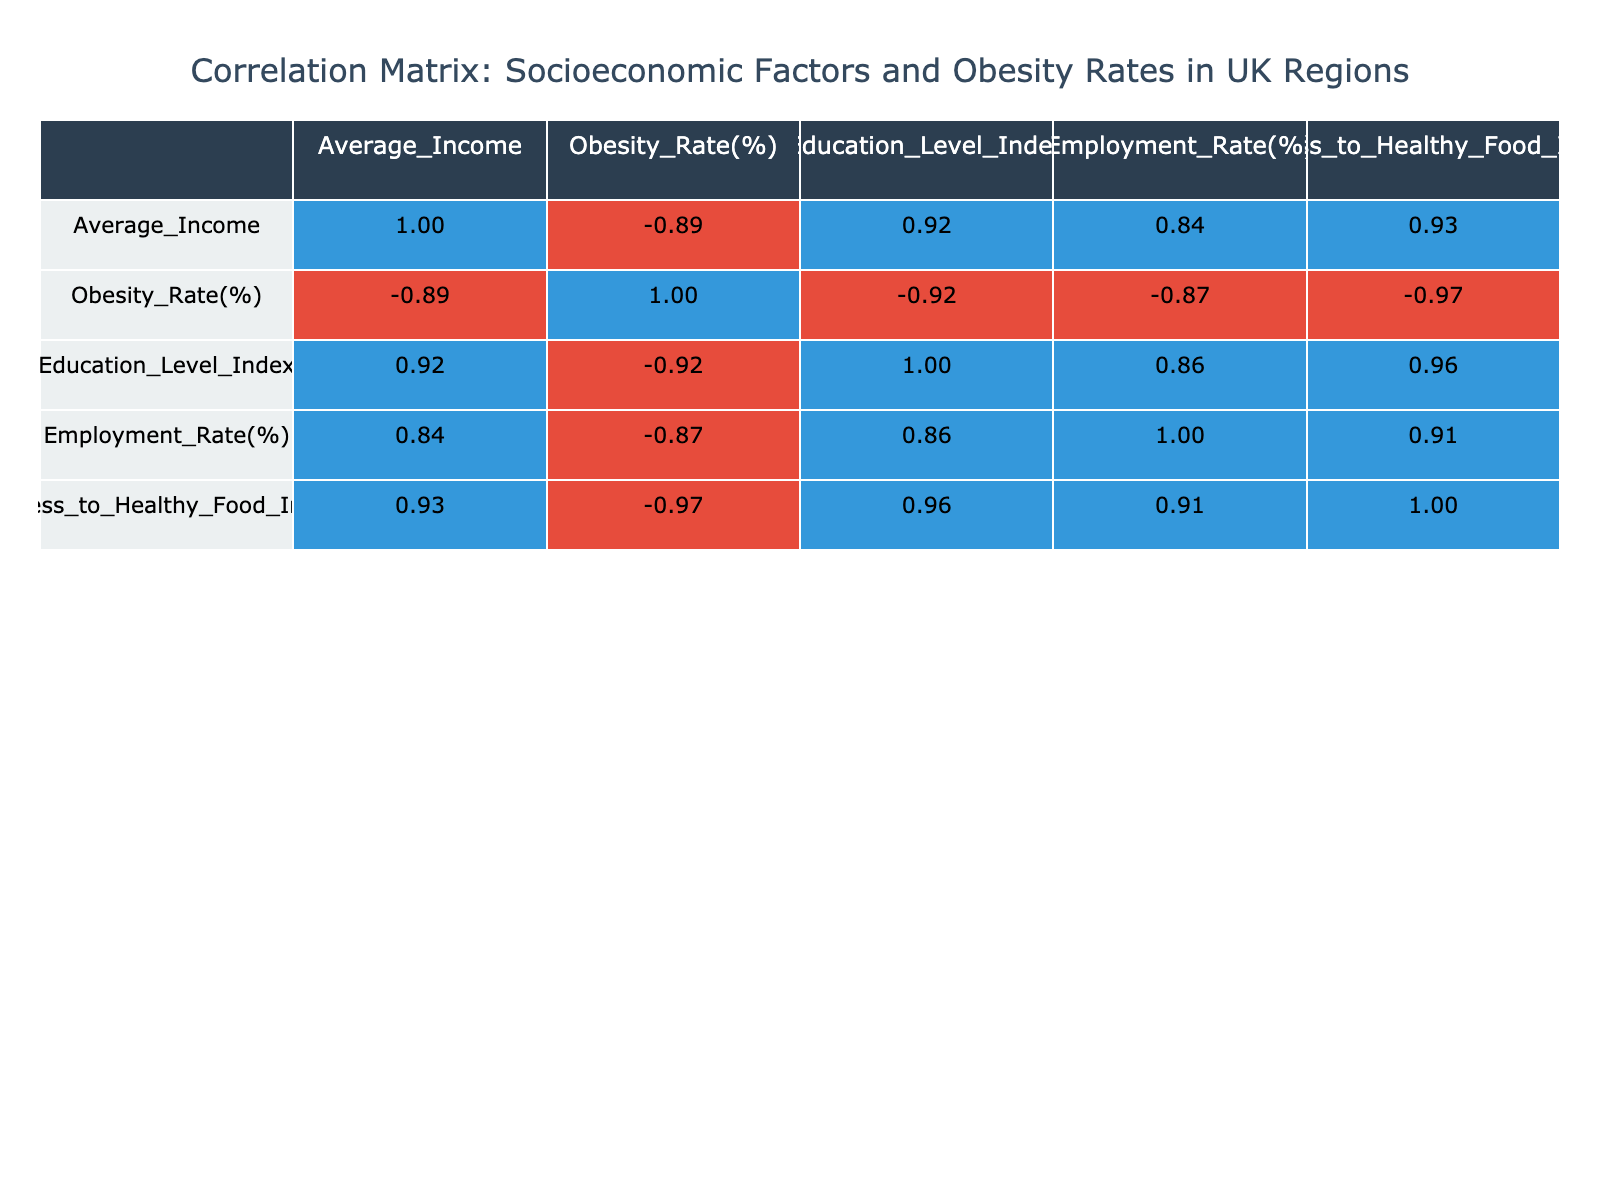What is the obesity rate in London? The obesity rate in London is listed directly in the table under the "Obesity Rate(%)" column for the region of London, which shows a value of 25.2%
Answer: 25.2% What is the average income of regions with an obesity rate over 30%? The regions with an obesity rate over 30% are North West (32.5%), Wales (31.7%), and North East (30.4%). Their average incomes are 28000, 27000, and 25000 respectively. Summing these gives 28000 + 27000 + 25000 = 80000, and dividing by 3 gives 80000 / 3 ≈ 26666.67
Answer: 26666.67 Is Scotland's access to healthy food index higher than that of Wales? The access to healthy food index for Scotland is 6.8, while for Wales it is 5.0. Since 6.8 is greater than 5.0, the statement is true
Answer: Yes Which region has the highest employment rate? The employment rates for all regions are compared. The highest value is found in the South East at 74.3%. By scanning the column for Employment Rate(%), it is confirmed to be the highest
Answer: 74.3% Does a higher average income correlate with a lower obesity rate based on the table? To determine this, we compare average incomes and obesity rates across the regions. For London with the highest income (40000) the obesity rate is 25.2%, and for the North East with the lowest income (25000) the obesity rate is 32.5%. This trend suggests that higher income relates to lower obesity rate
Answer: Yes What is the difference in obesity rates between the North East and the South East? The obesity rate in the North East is 32.5% and in the South East, it is 26.3%. The difference is calculated by subtracting: 32.5 - 26.3 = 6.2
Answer: 6.2 How many regions have an education level index below 6? The education level indices below 6 are found in North West (5.5), Wales (5.8), North East (5.0), and Northern Ireland (5.7). Counting these gives a total of 4 regions
Answer: 4 What is the average obesity rate for regions with an employment rate below 65%? The regions with an employment rate below 65% are North West (30.4%), Wales (31.7%), Yorkshire and the Humber (28.9%), and North East (32.5%). Summing these rates gives 30.4 + 31.7 + 28.9 + 32.5 = 123.5 and dividing by 4 gives an average of 123.5 / 4 = 30.875
Answer: 30.875 